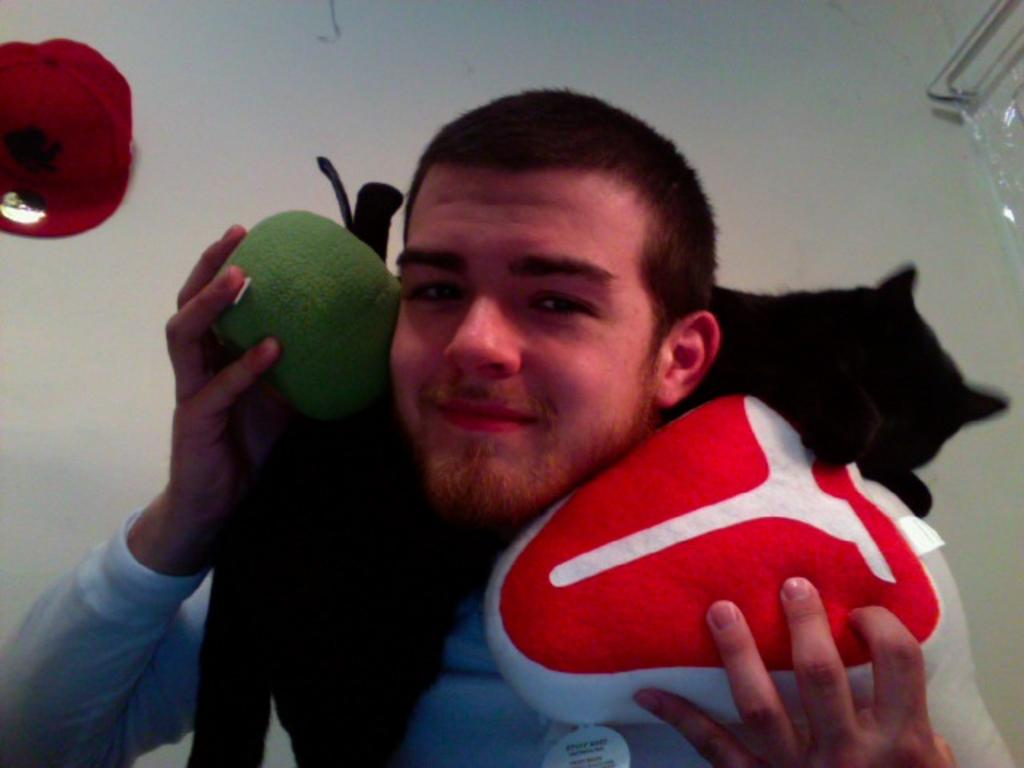Who is present in the image? There is a man in the image. What type of animal can be seen in the image? There is a black color cat in the image. What color is the wall in the image? There is a white color wall in the image. What is the rate of the lake's water flow in the image? There is no lake present in the image, so it is not possible to determine the rate of the lake's water flow. 